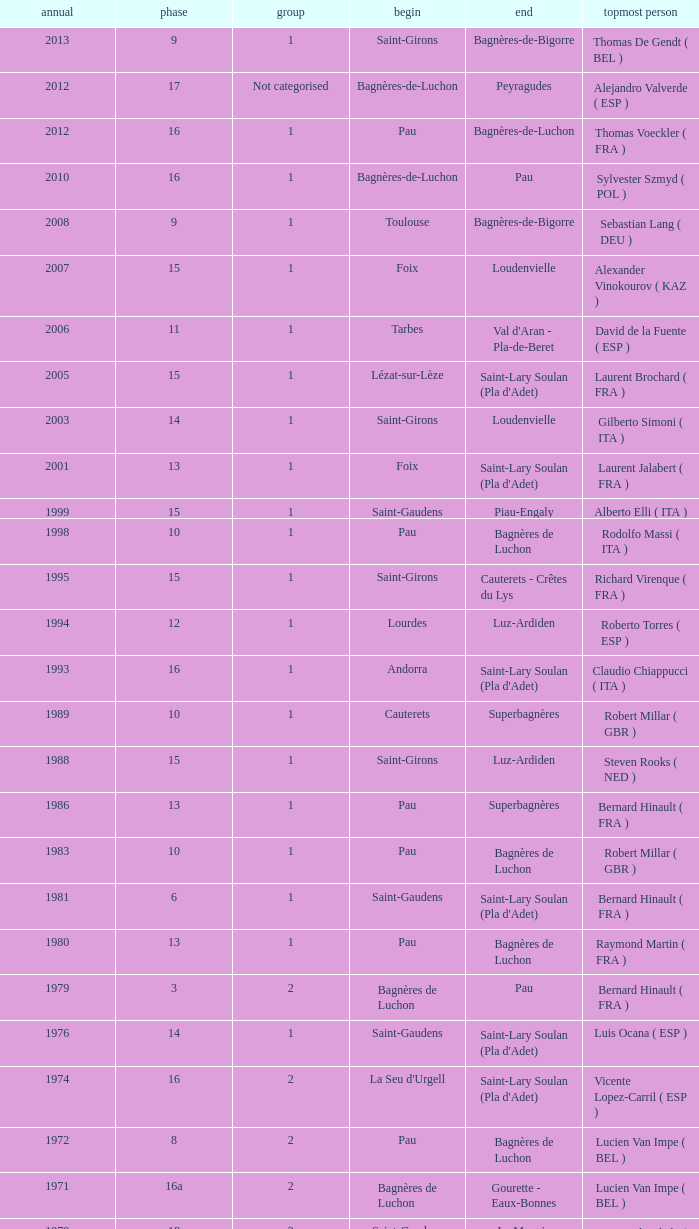What stage has a start of saint-girons in 1988? 15.0. Would you mind parsing the complete table? {'header': ['annual', 'phase', 'group', 'begin', 'end', 'topmost person'], 'rows': [['2013', '9', '1', 'Saint-Girons', 'Bagnères-de-Bigorre', 'Thomas De Gendt ( BEL )'], ['2012', '17', 'Not categorised', 'Bagnères-de-Luchon', 'Peyragudes', 'Alejandro Valverde ( ESP )'], ['2012', '16', '1', 'Pau', 'Bagnères-de-Luchon', 'Thomas Voeckler ( FRA )'], ['2010', '16', '1', 'Bagnères-de-Luchon', 'Pau', 'Sylvester Szmyd ( POL )'], ['2008', '9', '1', 'Toulouse', 'Bagnères-de-Bigorre', 'Sebastian Lang ( DEU )'], ['2007', '15', '1', 'Foix', 'Loudenvielle', 'Alexander Vinokourov ( KAZ )'], ['2006', '11', '1', 'Tarbes', "Val d'Aran - Pla-de-Beret", 'David de la Fuente ( ESP )'], ['2005', '15', '1', 'Lézat-sur-Lèze', "Saint-Lary Soulan (Pla d'Adet)", 'Laurent Brochard ( FRA )'], ['2003', '14', '1', 'Saint-Girons', 'Loudenvielle', 'Gilberto Simoni ( ITA )'], ['2001', '13', '1', 'Foix', "Saint-Lary Soulan (Pla d'Adet)", 'Laurent Jalabert ( FRA )'], ['1999', '15', '1', 'Saint-Gaudens', 'Piau-Engaly', 'Alberto Elli ( ITA )'], ['1998', '10', '1', 'Pau', 'Bagnères de Luchon', 'Rodolfo Massi ( ITA )'], ['1995', '15', '1', 'Saint-Girons', 'Cauterets - Crêtes du Lys', 'Richard Virenque ( FRA )'], ['1994', '12', '1', 'Lourdes', 'Luz-Ardiden', 'Roberto Torres ( ESP )'], ['1993', '16', '1', 'Andorra', "Saint-Lary Soulan (Pla d'Adet)", 'Claudio Chiappucci ( ITA )'], ['1989', '10', '1', 'Cauterets', 'Superbagnères', 'Robert Millar ( GBR )'], ['1988', '15', '1', 'Saint-Girons', 'Luz-Ardiden', 'Steven Rooks ( NED )'], ['1986', '13', '1', 'Pau', 'Superbagnères', 'Bernard Hinault ( FRA )'], ['1983', '10', '1', 'Pau', 'Bagnères de Luchon', 'Robert Millar ( GBR )'], ['1981', '6', '1', 'Saint-Gaudens', "Saint-Lary Soulan (Pla d'Adet)", 'Bernard Hinault ( FRA )'], ['1980', '13', '1', 'Pau', 'Bagnères de Luchon', 'Raymond Martin ( FRA )'], ['1979', '3', '2', 'Bagnères de Luchon', 'Pau', 'Bernard Hinault ( FRA )'], ['1976', '14', '1', 'Saint-Gaudens', "Saint-Lary Soulan (Pla d'Adet)", 'Luis Ocana ( ESP )'], ['1974', '16', '2', "La Seu d'Urgell", "Saint-Lary Soulan (Pla d'Adet)", 'Vicente Lopez-Carril ( ESP )'], ['1972', '8', '2', 'Pau', 'Bagnères de Luchon', 'Lucien Van Impe ( BEL )'], ['1971', '16a', '2', 'Bagnères de Luchon', 'Gourette - Eaux-Bonnes', 'Lucien Van Impe ( BEL )'], ['1970', '18', '2', 'Saint-Gaudens', 'La Mongie', 'Raymond Delisle ( FRA )'], ['1969', '17', '2', 'La Mongie', 'Mourenx', 'Joaquim Galera ( ESP )'], ['1964', '16', '2', 'Bagnères de Luchon', 'Pau', 'Julio Jiménez ( ESP )'], ['1963', '11', '2', 'Bagnères-de-Bigorre', 'Bagnères de Luchon', 'Federico Bahamontes ( ESP )'], ['1962', '12', '2', 'Pau', 'Saint-Gaudens', 'Federico Bahamontes ( ESP )'], ['1961', '17', '2', 'Bagnères de Luchon', 'Pau', 'Imerio Massignan ( ITA )'], ['1960', '11', '1', 'Pau', 'Bagnères de Luchon', 'Kurt Gimmi ( SUI )'], ['1959', '11', '1', 'Bagnères-de-Bigorre', 'Saint-Gaudens', 'Valentin Huot ( FRA )'], ['1958', '14', '1', 'Pau', 'Bagnères de Luchon', 'Federico Bahamontes ( ESP )'], ['1956', '12', 'Not categorised', 'Pau', 'Bagnères de Luchon', 'Jean-Pierre Schmitz ( LUX )'], ['1955', '17', '2', 'Toulouse', 'Saint-Gaudens', 'Charly Gaul ( LUX )'], ['1954', '12', '2', 'Pau', 'Bagnères de Luchon', 'Federico Bahamontes ( ESP )'], ['1953', '11', '2', 'Cauterets', 'Bagnères de Luchon', 'Jean Robic ( FRA )'], ['1952', '17', '2', 'Toulouse', 'Bagnères-de-Bigorre', 'Antonio Gelabert ( ESP )'], ['1951', '14', '2', 'Tarbes', 'Bagnères de Luchon', 'Fausto Coppi ( ITA )'], ['1949', '11', '2', 'Pau', 'Bagnères de Luchon', 'Jean Robic ( FRA )'], ['1948', '8', '2', 'Lourdes', 'Toulouse', 'Jean Robic ( FRA )'], ['1947', '15', '1', 'Bagnères de Luchon', 'Pau', 'Jean Robic ( FRA )']]} 